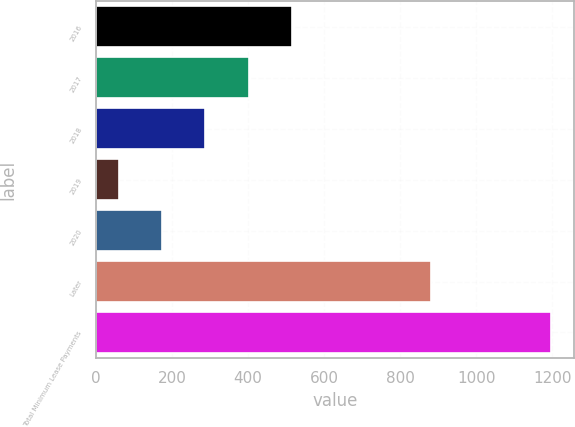<chart> <loc_0><loc_0><loc_500><loc_500><bar_chart><fcel>2016<fcel>2017<fcel>2018<fcel>2019<fcel>2020<fcel>Later<fcel>Total Minimum Lease Payments<nl><fcel>515.2<fcel>401.4<fcel>287.6<fcel>60<fcel>173.8<fcel>881<fcel>1198<nl></chart> 